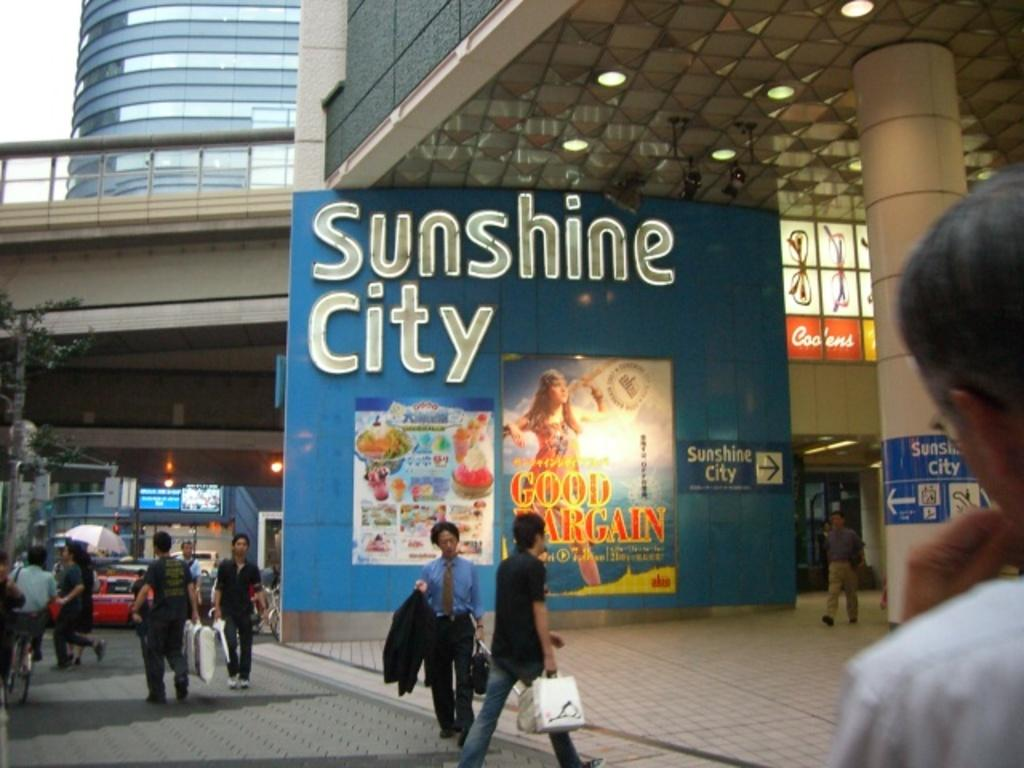<image>
Relay a brief, clear account of the picture shown. A big Sunshine City sign on the side of a building 